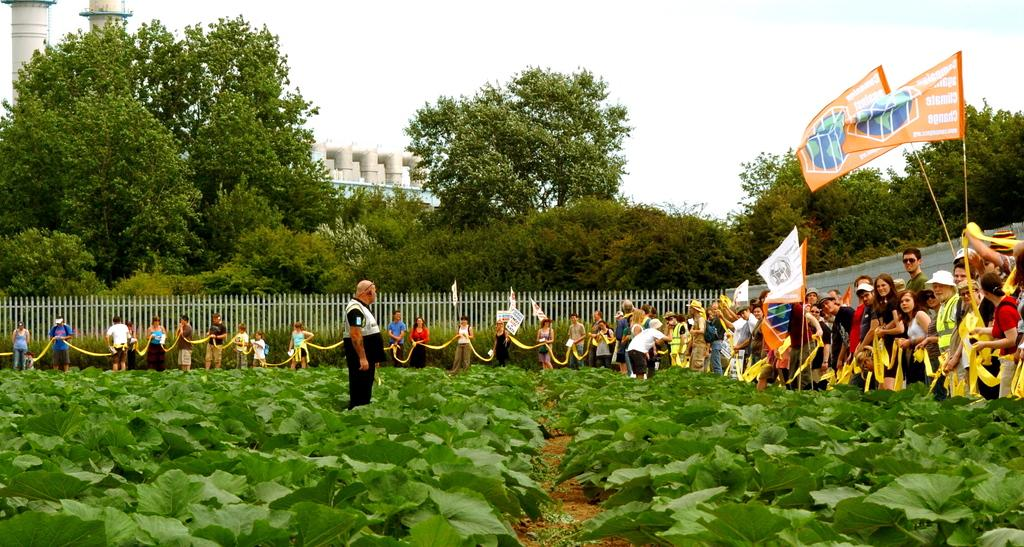Who or what can be seen in the image? There are people in the image. What else is present in the image besides people? There are plants, a fence, flags, trees, buildings, and the sky is visible in the image. Can you describe the plants in the image? The plants in the image are not specified, but they are present. What type of structures are visible in the image? There are buildings in the image. Can you see any squirrels jumping between the trees in the image? There is no mention of squirrels or jumping between trees in the image. 